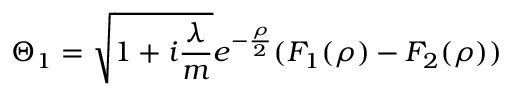Convert formula to latex. <formula><loc_0><loc_0><loc_500><loc_500>\Theta _ { 1 } = \sqrt { 1 + i \frac { \lambda } { m } } e ^ { - \frac { \rho } { 2 } } ( F _ { 1 } ( \rho ) - F _ { 2 } ( \rho ) )</formula> 